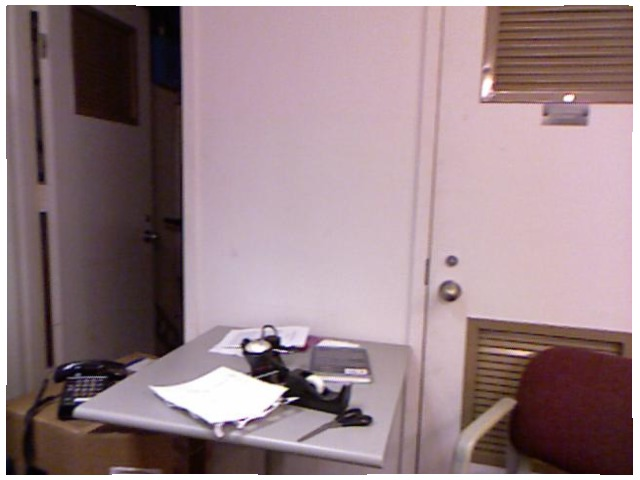<image>
Is the telephone on the desk? No. The telephone is not positioned on the desk. They may be near each other, but the telephone is not supported by or resting on top of the desk. Where is the wall in relation to the table? Is it behind the table? Yes. From this viewpoint, the wall is positioned behind the table, with the table partially or fully occluding the wall. Is there a scissor under the table? No. The scissor is not positioned under the table. The vertical relationship between these objects is different. 